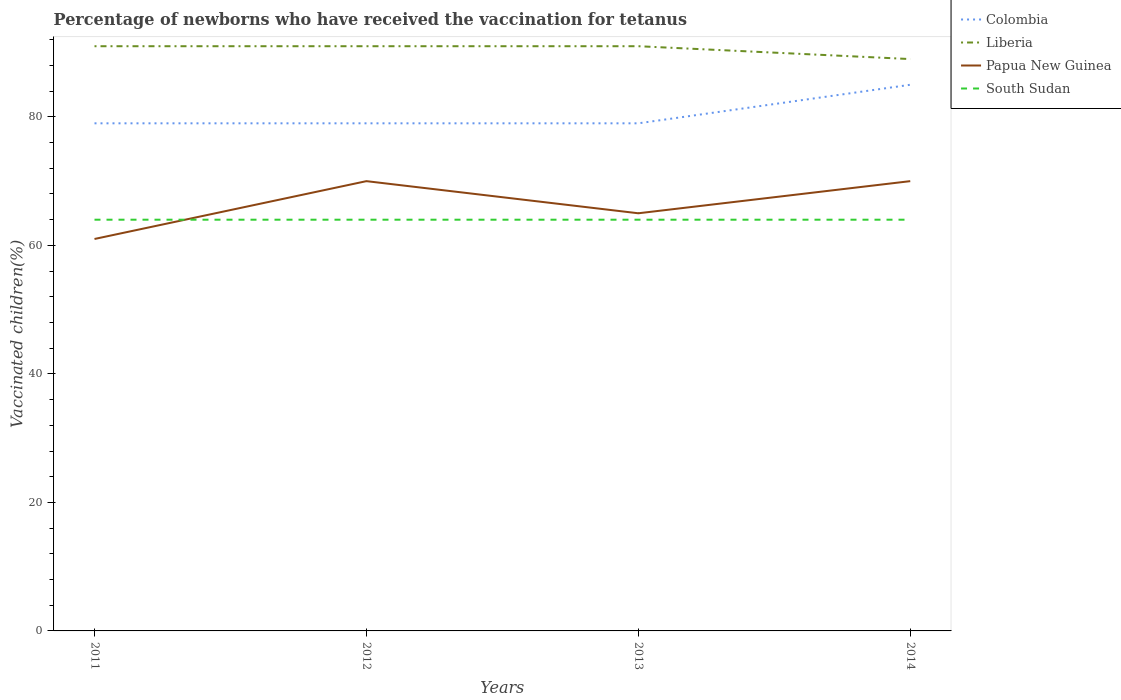How many different coloured lines are there?
Make the answer very short. 4. Is the number of lines equal to the number of legend labels?
Give a very brief answer. Yes. What is the total percentage of vaccinated children in South Sudan in the graph?
Make the answer very short. 0. What is the difference between the highest and the second highest percentage of vaccinated children in South Sudan?
Offer a very short reply. 0. How many lines are there?
Make the answer very short. 4. How many years are there in the graph?
Ensure brevity in your answer.  4. What is the difference between two consecutive major ticks on the Y-axis?
Offer a terse response. 20. Does the graph contain grids?
Your answer should be very brief. No. Where does the legend appear in the graph?
Keep it short and to the point. Top right. How many legend labels are there?
Provide a short and direct response. 4. What is the title of the graph?
Provide a succinct answer. Percentage of newborns who have received the vaccination for tetanus. What is the label or title of the X-axis?
Provide a succinct answer. Years. What is the label or title of the Y-axis?
Make the answer very short. Vaccinated children(%). What is the Vaccinated children(%) in Colombia in 2011?
Give a very brief answer. 79. What is the Vaccinated children(%) of Liberia in 2011?
Ensure brevity in your answer.  91. What is the Vaccinated children(%) in Papua New Guinea in 2011?
Provide a succinct answer. 61. What is the Vaccinated children(%) in South Sudan in 2011?
Provide a short and direct response. 64. What is the Vaccinated children(%) in Colombia in 2012?
Provide a succinct answer. 79. What is the Vaccinated children(%) of Liberia in 2012?
Ensure brevity in your answer.  91. What is the Vaccinated children(%) in Papua New Guinea in 2012?
Your answer should be very brief. 70. What is the Vaccinated children(%) in South Sudan in 2012?
Give a very brief answer. 64. What is the Vaccinated children(%) of Colombia in 2013?
Give a very brief answer. 79. What is the Vaccinated children(%) of Liberia in 2013?
Provide a short and direct response. 91. What is the Vaccinated children(%) in South Sudan in 2013?
Your answer should be very brief. 64. What is the Vaccinated children(%) of Colombia in 2014?
Make the answer very short. 85. What is the Vaccinated children(%) in Liberia in 2014?
Provide a short and direct response. 89. What is the Vaccinated children(%) of Papua New Guinea in 2014?
Ensure brevity in your answer.  70. What is the Vaccinated children(%) of South Sudan in 2014?
Your answer should be compact. 64. Across all years, what is the maximum Vaccinated children(%) in Colombia?
Ensure brevity in your answer.  85. Across all years, what is the maximum Vaccinated children(%) of Liberia?
Provide a short and direct response. 91. Across all years, what is the maximum Vaccinated children(%) of Papua New Guinea?
Keep it short and to the point. 70. Across all years, what is the maximum Vaccinated children(%) of South Sudan?
Offer a terse response. 64. Across all years, what is the minimum Vaccinated children(%) of Colombia?
Make the answer very short. 79. Across all years, what is the minimum Vaccinated children(%) in Liberia?
Offer a very short reply. 89. Across all years, what is the minimum Vaccinated children(%) of Papua New Guinea?
Your answer should be compact. 61. What is the total Vaccinated children(%) in Colombia in the graph?
Your answer should be very brief. 322. What is the total Vaccinated children(%) in Liberia in the graph?
Ensure brevity in your answer.  362. What is the total Vaccinated children(%) of Papua New Guinea in the graph?
Provide a succinct answer. 266. What is the total Vaccinated children(%) of South Sudan in the graph?
Offer a terse response. 256. What is the difference between the Vaccinated children(%) in Liberia in 2011 and that in 2012?
Provide a succinct answer. 0. What is the difference between the Vaccinated children(%) in Papua New Guinea in 2011 and that in 2012?
Provide a succinct answer. -9. What is the difference between the Vaccinated children(%) of Colombia in 2011 and that in 2013?
Your answer should be very brief. 0. What is the difference between the Vaccinated children(%) in Liberia in 2011 and that in 2013?
Ensure brevity in your answer.  0. What is the difference between the Vaccinated children(%) in South Sudan in 2011 and that in 2013?
Ensure brevity in your answer.  0. What is the difference between the Vaccinated children(%) of Colombia in 2011 and that in 2014?
Your answer should be very brief. -6. What is the difference between the Vaccinated children(%) in Liberia in 2011 and that in 2014?
Give a very brief answer. 2. What is the difference between the Vaccinated children(%) in South Sudan in 2011 and that in 2014?
Your response must be concise. 0. What is the difference between the Vaccinated children(%) of Liberia in 2012 and that in 2013?
Offer a terse response. 0. What is the difference between the Vaccinated children(%) in Liberia in 2012 and that in 2014?
Provide a short and direct response. 2. What is the difference between the Vaccinated children(%) in Liberia in 2013 and that in 2014?
Keep it short and to the point. 2. What is the difference between the Vaccinated children(%) of Papua New Guinea in 2013 and that in 2014?
Make the answer very short. -5. What is the difference between the Vaccinated children(%) in South Sudan in 2013 and that in 2014?
Make the answer very short. 0. What is the difference between the Vaccinated children(%) of Colombia in 2011 and the Vaccinated children(%) of Liberia in 2012?
Give a very brief answer. -12. What is the difference between the Vaccinated children(%) in Colombia in 2011 and the Vaccinated children(%) in South Sudan in 2012?
Ensure brevity in your answer.  15. What is the difference between the Vaccinated children(%) in Papua New Guinea in 2011 and the Vaccinated children(%) in South Sudan in 2012?
Offer a terse response. -3. What is the difference between the Vaccinated children(%) in Colombia in 2011 and the Vaccinated children(%) in Liberia in 2013?
Offer a very short reply. -12. What is the difference between the Vaccinated children(%) of Liberia in 2011 and the Vaccinated children(%) of South Sudan in 2013?
Keep it short and to the point. 27. What is the difference between the Vaccinated children(%) in Papua New Guinea in 2011 and the Vaccinated children(%) in South Sudan in 2013?
Make the answer very short. -3. What is the difference between the Vaccinated children(%) in Colombia in 2011 and the Vaccinated children(%) in Liberia in 2014?
Give a very brief answer. -10. What is the difference between the Vaccinated children(%) of Colombia in 2011 and the Vaccinated children(%) of Papua New Guinea in 2014?
Provide a succinct answer. 9. What is the difference between the Vaccinated children(%) of Colombia in 2011 and the Vaccinated children(%) of South Sudan in 2014?
Provide a succinct answer. 15. What is the difference between the Vaccinated children(%) in Colombia in 2012 and the Vaccinated children(%) in Liberia in 2013?
Your answer should be very brief. -12. What is the difference between the Vaccinated children(%) of Colombia in 2012 and the Vaccinated children(%) of Papua New Guinea in 2013?
Your response must be concise. 14. What is the difference between the Vaccinated children(%) of Liberia in 2012 and the Vaccinated children(%) of Papua New Guinea in 2013?
Provide a short and direct response. 26. What is the difference between the Vaccinated children(%) in Colombia in 2012 and the Vaccinated children(%) in Papua New Guinea in 2014?
Ensure brevity in your answer.  9. What is the difference between the Vaccinated children(%) in Liberia in 2012 and the Vaccinated children(%) in Papua New Guinea in 2014?
Offer a terse response. 21. What is the difference between the Vaccinated children(%) in Liberia in 2012 and the Vaccinated children(%) in South Sudan in 2014?
Ensure brevity in your answer.  27. What is the difference between the Vaccinated children(%) of Papua New Guinea in 2012 and the Vaccinated children(%) of South Sudan in 2014?
Offer a terse response. 6. What is the difference between the Vaccinated children(%) of Liberia in 2013 and the Vaccinated children(%) of South Sudan in 2014?
Offer a very short reply. 27. What is the difference between the Vaccinated children(%) in Papua New Guinea in 2013 and the Vaccinated children(%) in South Sudan in 2014?
Your response must be concise. 1. What is the average Vaccinated children(%) of Colombia per year?
Your response must be concise. 80.5. What is the average Vaccinated children(%) in Liberia per year?
Ensure brevity in your answer.  90.5. What is the average Vaccinated children(%) of Papua New Guinea per year?
Offer a terse response. 66.5. In the year 2011, what is the difference between the Vaccinated children(%) of Colombia and Vaccinated children(%) of Liberia?
Your answer should be very brief. -12. In the year 2011, what is the difference between the Vaccinated children(%) of Liberia and Vaccinated children(%) of Papua New Guinea?
Provide a short and direct response. 30. In the year 2011, what is the difference between the Vaccinated children(%) in Liberia and Vaccinated children(%) in South Sudan?
Ensure brevity in your answer.  27. In the year 2012, what is the difference between the Vaccinated children(%) of Colombia and Vaccinated children(%) of Papua New Guinea?
Make the answer very short. 9. In the year 2012, what is the difference between the Vaccinated children(%) of Liberia and Vaccinated children(%) of Papua New Guinea?
Keep it short and to the point. 21. In the year 2012, what is the difference between the Vaccinated children(%) of Liberia and Vaccinated children(%) of South Sudan?
Provide a short and direct response. 27. In the year 2013, what is the difference between the Vaccinated children(%) in Colombia and Vaccinated children(%) in Liberia?
Offer a very short reply. -12. In the year 2013, what is the difference between the Vaccinated children(%) of Colombia and Vaccinated children(%) of Papua New Guinea?
Give a very brief answer. 14. In the year 2013, what is the difference between the Vaccinated children(%) in Colombia and Vaccinated children(%) in South Sudan?
Provide a short and direct response. 15. In the year 2013, what is the difference between the Vaccinated children(%) in Liberia and Vaccinated children(%) in South Sudan?
Make the answer very short. 27. In the year 2013, what is the difference between the Vaccinated children(%) in Papua New Guinea and Vaccinated children(%) in South Sudan?
Ensure brevity in your answer.  1. In the year 2014, what is the difference between the Vaccinated children(%) of Colombia and Vaccinated children(%) of Papua New Guinea?
Offer a terse response. 15. In the year 2014, what is the difference between the Vaccinated children(%) in Liberia and Vaccinated children(%) in Papua New Guinea?
Your answer should be compact. 19. In the year 2014, what is the difference between the Vaccinated children(%) in Papua New Guinea and Vaccinated children(%) in South Sudan?
Give a very brief answer. 6. What is the ratio of the Vaccinated children(%) in Colombia in 2011 to that in 2012?
Your answer should be compact. 1. What is the ratio of the Vaccinated children(%) in Liberia in 2011 to that in 2012?
Keep it short and to the point. 1. What is the ratio of the Vaccinated children(%) in Papua New Guinea in 2011 to that in 2012?
Your response must be concise. 0.87. What is the ratio of the Vaccinated children(%) of South Sudan in 2011 to that in 2012?
Your answer should be very brief. 1. What is the ratio of the Vaccinated children(%) of Liberia in 2011 to that in 2013?
Offer a terse response. 1. What is the ratio of the Vaccinated children(%) of Papua New Guinea in 2011 to that in 2013?
Offer a terse response. 0.94. What is the ratio of the Vaccinated children(%) of South Sudan in 2011 to that in 2013?
Offer a terse response. 1. What is the ratio of the Vaccinated children(%) in Colombia in 2011 to that in 2014?
Offer a terse response. 0.93. What is the ratio of the Vaccinated children(%) of Liberia in 2011 to that in 2014?
Provide a succinct answer. 1.02. What is the ratio of the Vaccinated children(%) in Papua New Guinea in 2011 to that in 2014?
Keep it short and to the point. 0.87. What is the ratio of the Vaccinated children(%) in Colombia in 2012 to that in 2013?
Offer a terse response. 1. What is the ratio of the Vaccinated children(%) in Papua New Guinea in 2012 to that in 2013?
Your answer should be very brief. 1.08. What is the ratio of the Vaccinated children(%) in South Sudan in 2012 to that in 2013?
Make the answer very short. 1. What is the ratio of the Vaccinated children(%) of Colombia in 2012 to that in 2014?
Give a very brief answer. 0.93. What is the ratio of the Vaccinated children(%) of Liberia in 2012 to that in 2014?
Offer a very short reply. 1.02. What is the ratio of the Vaccinated children(%) of South Sudan in 2012 to that in 2014?
Give a very brief answer. 1. What is the ratio of the Vaccinated children(%) in Colombia in 2013 to that in 2014?
Provide a succinct answer. 0.93. What is the ratio of the Vaccinated children(%) of Liberia in 2013 to that in 2014?
Make the answer very short. 1.02. What is the ratio of the Vaccinated children(%) in Papua New Guinea in 2013 to that in 2014?
Provide a succinct answer. 0.93. What is the difference between the highest and the second highest Vaccinated children(%) in Liberia?
Provide a short and direct response. 0. What is the difference between the highest and the lowest Vaccinated children(%) of Colombia?
Offer a terse response. 6. What is the difference between the highest and the lowest Vaccinated children(%) of Papua New Guinea?
Your answer should be very brief. 9. What is the difference between the highest and the lowest Vaccinated children(%) in South Sudan?
Make the answer very short. 0. 